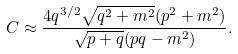Convert formula to latex. <formula><loc_0><loc_0><loc_500><loc_500>C \approx \frac { 4 q ^ { 3 / 2 } \sqrt { q ^ { 2 } + m ^ { 2 } } ( p ^ { 2 } + m ^ { 2 } ) } { \sqrt { p + q } ( p q - m ^ { 2 } ) } .</formula> 